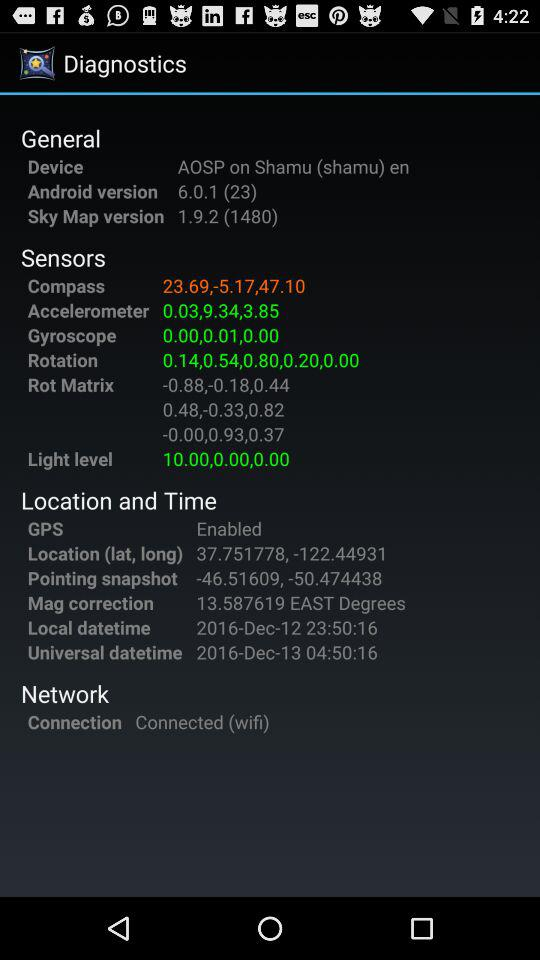What is the status of "GPS"? The status of "GPS" is "Enabled". 